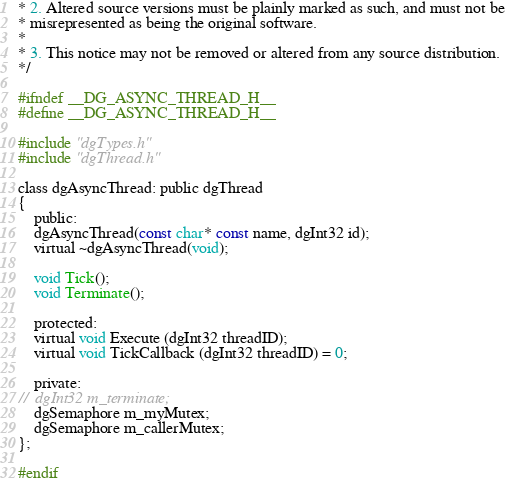<code> <loc_0><loc_0><loc_500><loc_500><_C_>* 2. Altered source versions must be plainly marked as such, and must not be
* misrepresented as being the original software.
* 
* 3. This notice may not be removed or altered from any source distribution.
*/

#ifndef __DG_ASYNC_THREAD_H__
#define __DG_ASYNC_THREAD_H__

#include "dgTypes.h"
#include "dgThread.h"

class dgAsyncThread: public dgThread
{
	public:
	dgAsyncThread(const char* const name, dgInt32 id);
	virtual ~dgAsyncThread(void);

	void Tick(); 
	void Terminate(); 

	protected:
	virtual void Execute (dgInt32 threadID);
	virtual void TickCallback (dgInt32 threadID) = 0;

	private:
//	dgInt32 m_terminate;
	dgSemaphore m_myMutex;
	dgSemaphore m_callerMutex;
};

#endif</code> 